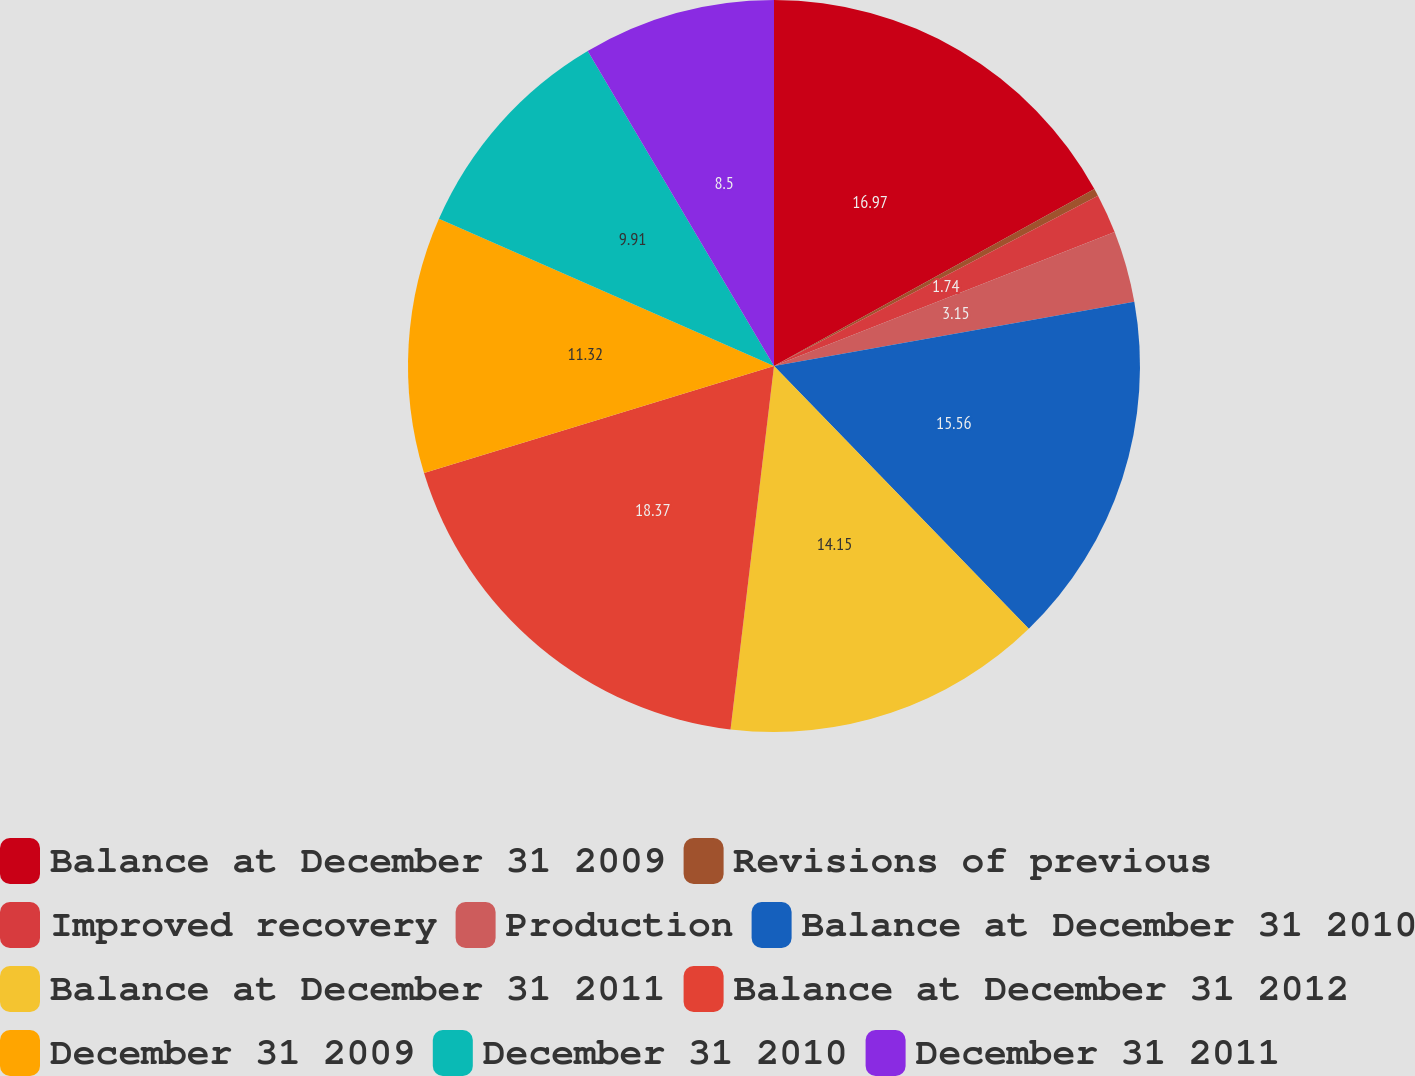Convert chart. <chart><loc_0><loc_0><loc_500><loc_500><pie_chart><fcel>Balance at December 31 2009<fcel>Revisions of previous<fcel>Improved recovery<fcel>Production<fcel>Balance at December 31 2010<fcel>Balance at December 31 2011<fcel>Balance at December 31 2012<fcel>December 31 2009<fcel>December 31 2010<fcel>December 31 2011<nl><fcel>16.97%<fcel>0.33%<fcel>1.74%<fcel>3.15%<fcel>15.56%<fcel>14.15%<fcel>18.38%<fcel>11.32%<fcel>9.91%<fcel>8.5%<nl></chart> 